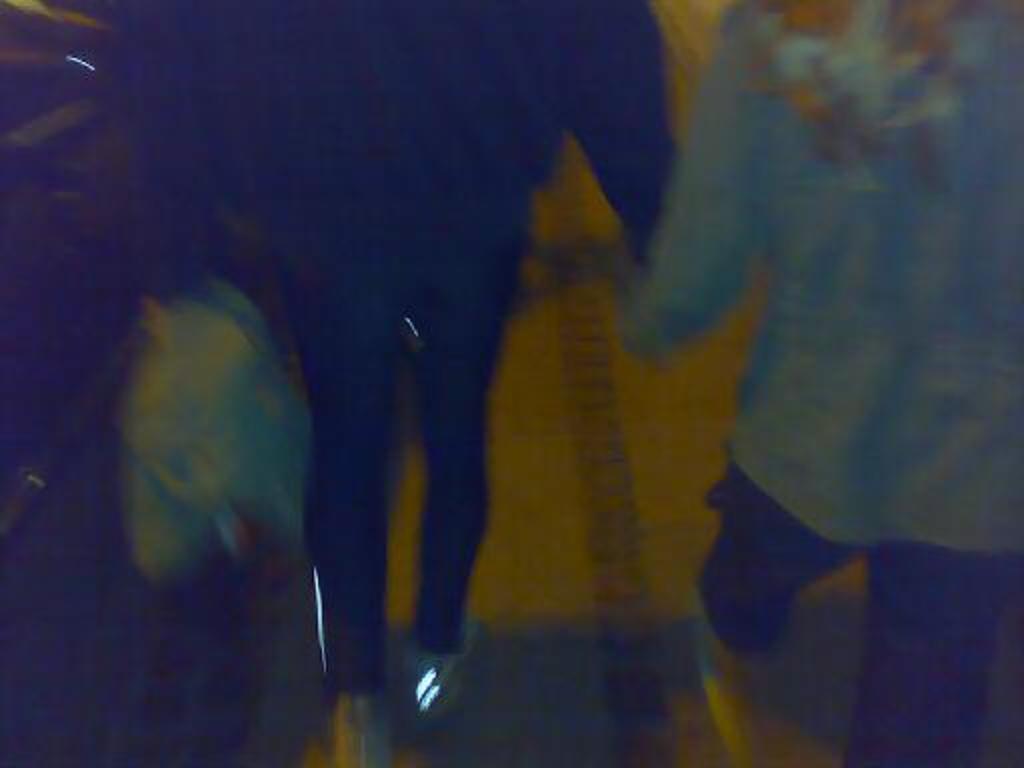Can you describe this image briefly? In this picture we can see two people holding hands and walking on a platform. 